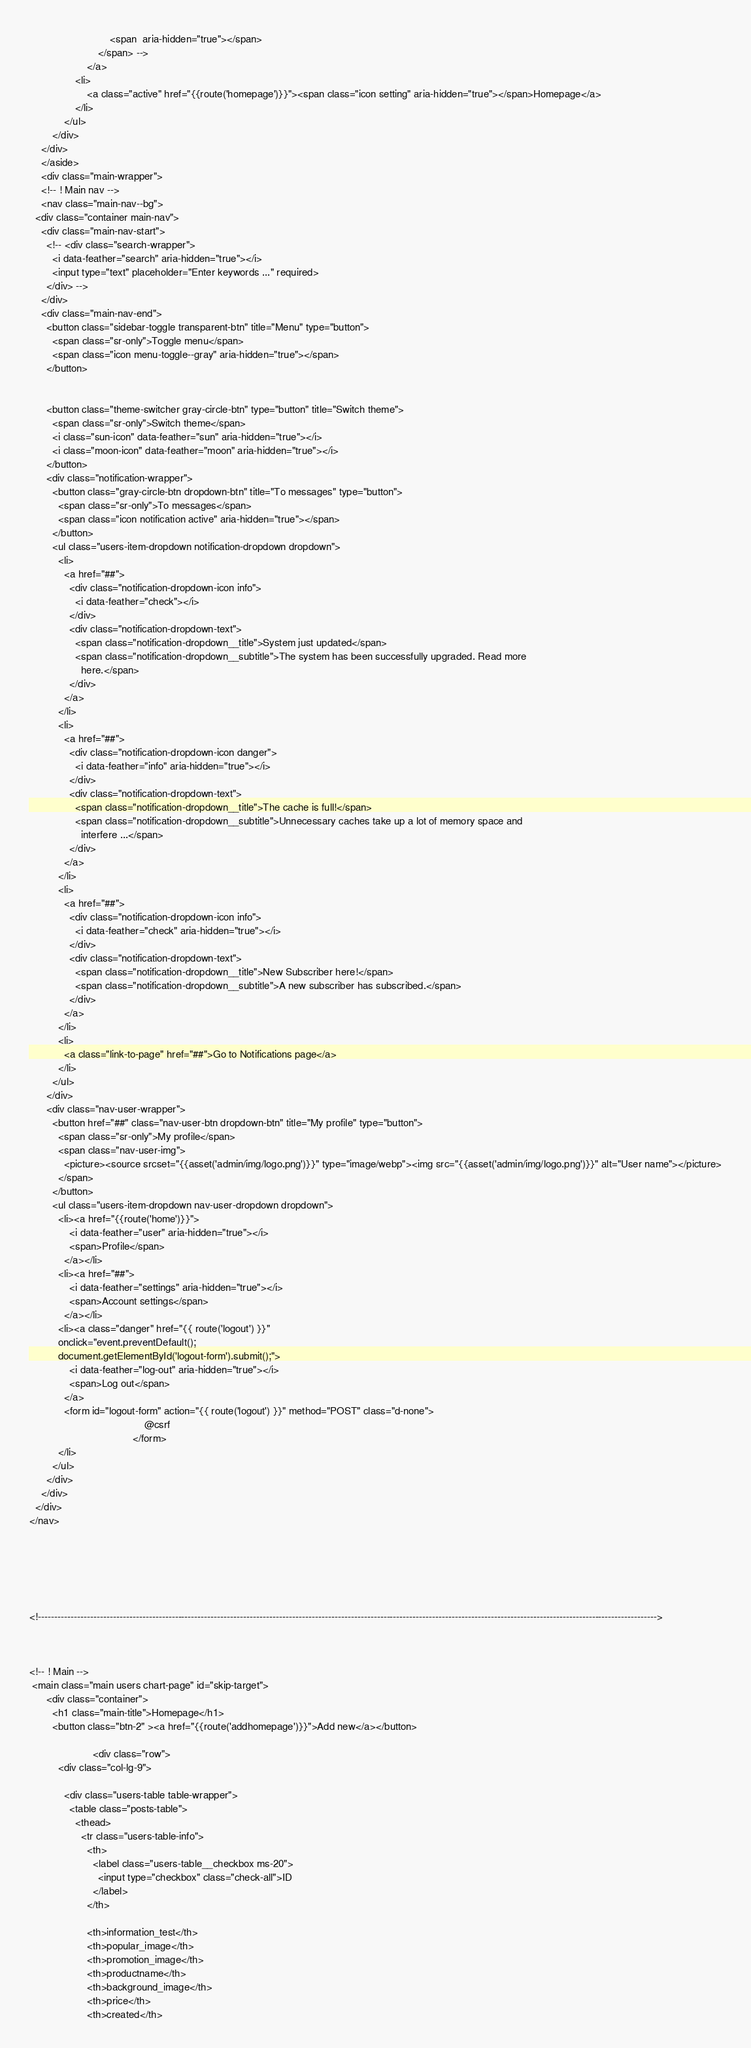<code> <loc_0><loc_0><loc_500><loc_500><_PHP_>                            <span  aria-hidden="true"></span>
                        </span> -->
                    </a>
                <li>
                    <a class="active" href="{{route('homepage')}}"><span class="icon setting" aria-hidden="true"></span>Homepage</a>
                </li>
            </ul>
        </div>
    </div>
    </aside>
    <div class="main-wrapper">
    <!-- ! Main nav -->
    <nav class="main-nav--bg">
  <div class="container main-nav">
    <div class="main-nav-start">
      <!-- <div class="search-wrapper">
        <i data-feather="search" aria-hidden="true"></i>
        <input type="text" placeholder="Enter keywords ..." required>
      </div> -->
    </div>
    <div class="main-nav-end">
      <button class="sidebar-toggle transparent-btn" title="Menu" type="button">
        <span class="sr-only">Toggle menu</span>
        <span class="icon menu-toggle--gray" aria-hidden="true"></span>
      </button>
     

      <button class="theme-switcher gray-circle-btn" type="button" title="Switch theme">
        <span class="sr-only">Switch theme</span>
        <i class="sun-icon" data-feather="sun" aria-hidden="true"></i>
        <i class="moon-icon" data-feather="moon" aria-hidden="true"></i>
      </button>
      <div class="notification-wrapper">
        <button class="gray-circle-btn dropdown-btn" title="To messages" type="button">
          <span class="sr-only">To messages</span>
          <span class="icon notification active" aria-hidden="true"></span>
        </button>
        <ul class="users-item-dropdown notification-dropdown dropdown">
          <li>
            <a href="##">
              <div class="notification-dropdown-icon info">
                <i data-feather="check"></i>
              </div>
              <div class="notification-dropdown-text">
                <span class="notification-dropdown__title">System just updated</span>
                <span class="notification-dropdown__subtitle">The system has been successfully upgraded. Read more
                  here.</span>
              </div>
            </a>
          </li>
          <li>
            <a href="##">
              <div class="notification-dropdown-icon danger">
                <i data-feather="info" aria-hidden="true"></i>
              </div>
              <div class="notification-dropdown-text">
                <span class="notification-dropdown__title">The cache is full!</span>
                <span class="notification-dropdown__subtitle">Unnecessary caches take up a lot of memory space and
                  interfere ...</span>
              </div>
            </a>
          </li>
          <li>
            <a href="##">
              <div class="notification-dropdown-icon info">
                <i data-feather="check" aria-hidden="true"></i>
              </div>
              <div class="notification-dropdown-text">
                <span class="notification-dropdown__title">New Subscriber here!</span>
                <span class="notification-dropdown__subtitle">A new subscriber has subscribed.</span>
              </div>
            </a>
          </li>
          <li>
            <a class="link-to-page" href="##">Go to Notifications page</a>
          </li>
        </ul>
      </div>
      <div class="nav-user-wrapper">
        <button href="##" class="nav-user-btn dropdown-btn" title="My profile" type="button">
          <span class="sr-only">My profile</span>
          <span class="nav-user-img">
            <picture><source srcset="{{asset('admin/img/logo.png')}}" type="image/webp"><img src="{{asset('admin/img/logo.png')}}" alt="User name"></picture>
          </span>
        </button>
        <ul class="users-item-dropdown nav-user-dropdown dropdown">
          <li><a href="{{route('home')}}">
              <i data-feather="user" aria-hidden="true"></i>
              <span>Profile</span>
            </a></li>
          <li><a href="##">
              <i data-feather="settings" aria-hidden="true"></i>
              <span>Account settings</span>
            </a></li>
          <li><a class="danger" href="{{ route('logout') }}"
          onclick="event.preventDefault();
          document.getElementById('logout-form').submit();">
              <i data-feather="log-out" aria-hidden="true"></i>
              <span>Log out</span>
            </a>
            <form id="logout-form" action="{{ route('logout') }}" method="POST" class="d-none">
                                        @csrf
                                    </form>
          </li>
        </ul>
      </div>
    </div>
  </div>
</nav>






<!---------------------------------------------------------------------------------------------------------------------------------------------------------------------------------------------->
  


<!-- ! Main -->
 <main class="main users chart-page" id="skip-target">
      <div class="container">
        <h1 class="main-title">Homepage</h1>
        <button class="btn-2" ><a href="{{route('addhomepage')}}">Add new</a></button>
        
                      <div class="row">
          <div class="col-lg-9">
          
            <div class="users-table table-wrapper">
              <table class="posts-table">
                <thead>
                  <tr class="users-table-info">
                    <th>
                      <label class="users-table__checkbox ms-20">
                        <input type="checkbox" class="check-all">ID
                      </label>
                    </th>
                    
                    <th>information_test</th>
                    <th>popular_image</th>
                    <th>promotion_image</th>
                    <th>productname</th>
                    <th>background_image</th>
                    <th>price</th>
                    <th>created</th></code> 